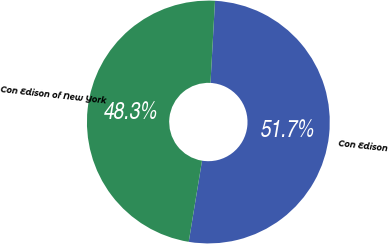Convert chart. <chart><loc_0><loc_0><loc_500><loc_500><pie_chart><fcel>Con Edison<fcel>Con Edison of New York<nl><fcel>51.71%<fcel>48.29%<nl></chart> 